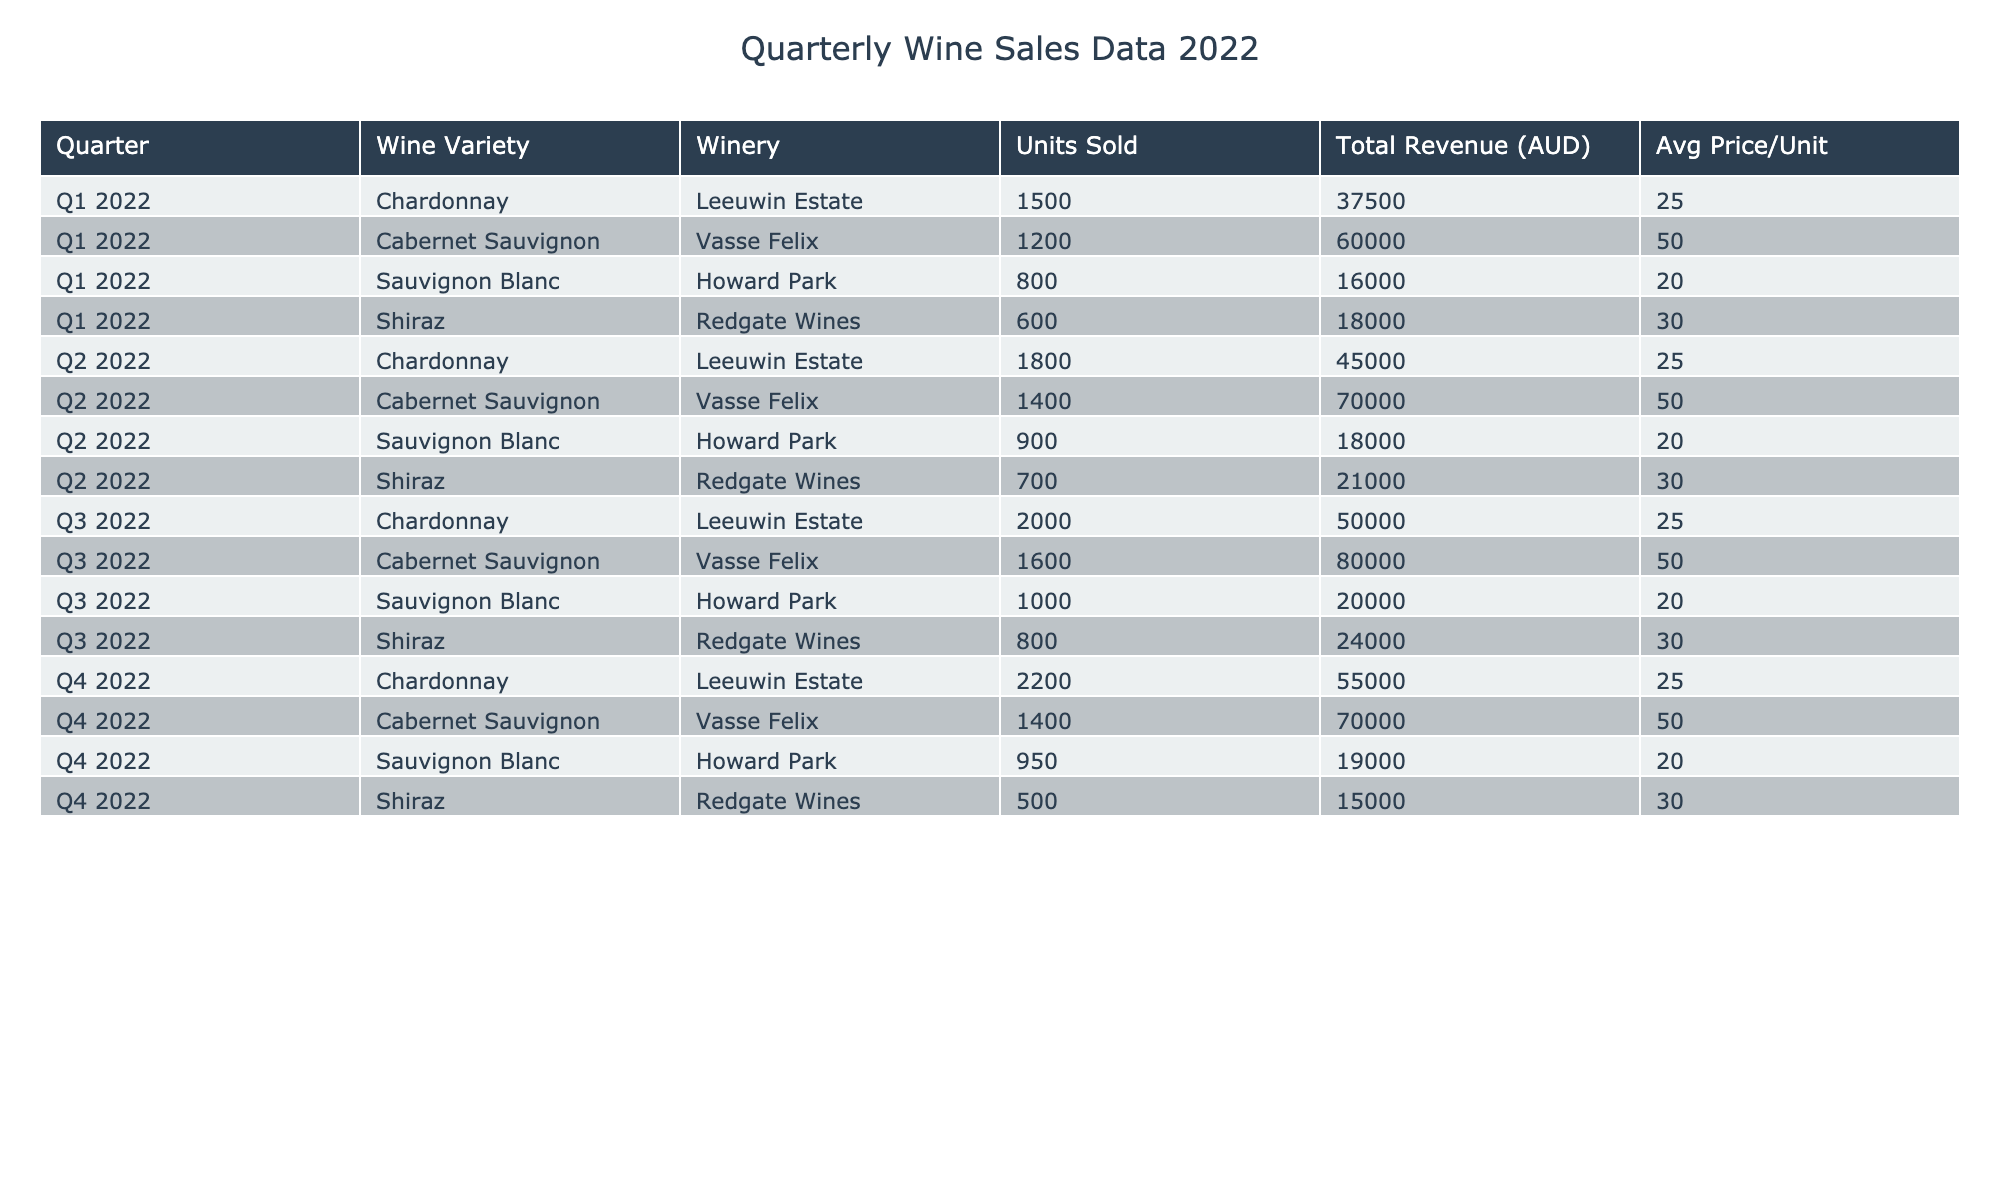What was the total revenue generated from Chardonnay sales in 2022? To find the total revenue for Chardonnay, we sum up the total revenue from all quarters: 37500 (Q1) + 45000 (Q2) + 50000 (Q3) + 55000 (Q4) = 187500 AUD.
Answer: 187500 AUD Which winery sold the most Cabernet Sauvignon in 2022? By looking at the units sold for Cabernet Sauvignon across all quarters, Vasse Felix sold 1200 (Q1), 1400 (Q2), 1600 (Q3), and 1400 (Q4). The maximum is 1600 in Q3, making Vasse Felix the top seller.
Answer: Vasse Felix What was the average number of units sold for Sauvignon Blanc across all quarters? Sum the units sold for Sauvignon Blanc: 800 (Q1) + 900 (Q2) + 1000 (Q3) + 950 (Q4) = 3650. Divide by 4 (the number of quarters) to find the average: 3650 / 4 = 912.5.
Answer: 912.5 Was the total revenue from Shiraz sales higher in Q1 or Q4? The total revenue for Shiraz in Q1 is 18000, while in Q4 it is 15000. Since 18000 > 15000, Shiraz sales generated more revenue in Q1 compared to Q4.
Answer: Yes, Q1 What was the total revenue generated from all types of wine in Q3 2022? To find the total revenue for Q3, we sum the revenues: Chardonnay 50000 + Cabernet Sauvignon 80000 + Sauvignon Blanc 20000 + Shiraz 24000 = 174000 AUD.
Answer: 174000 AUD How many units of Cabernet Sauvignon were sold in Q2 and Q4 combined? For Cabernet Sauvignon, the units sold in Q2 is 1400 and in Q4 is 1400 as well. Adding both gives us 1400 + 1400 = 2800 units sold.
Answer: 2800 Which quarter had the highest total revenue from wine sales? We need to calculate the total revenue for each quarter. Q1: 37500 + 60000 + 16000 + 18000 = 131500, Q2: 45000 + 70000 + 18000 + 21000 = 154000, Q3: 50000 + 80000 + 20000 + 24000 = 174000, Q4: 55000 + 70000 + 19000 + 15000 = 159000. Q3 had the highest at 174000.
Answer: Q3 Which wine variety had the lowest total revenue for the year? By calculating total revenue for each wine: Chardonnay = 187500, Cabernet Sauvignon = 280000, Sauvignon Blanc = 73000, Shiraz = 78000. The lowest is for Sauvignon Blanc at 73000 AUD.
Answer: Sauvignon Blanc What is the total number of units sold for all varieties in Q1? Sum of units sold in Q1: Chardonnay 1500 + Cabernet Sauvignon 1200 + Sauvignon Blanc 800 + Shiraz 600 = 3100 units.
Answer: 3100 In which quarter did Howard Park sell the most Sauvignon Blanc? Howard Park sold 800 in Q1, 900 in Q2, 1000 in Q3, and 950 in Q4. The most was in Q3 with 1000 units sold.
Answer: Q3 